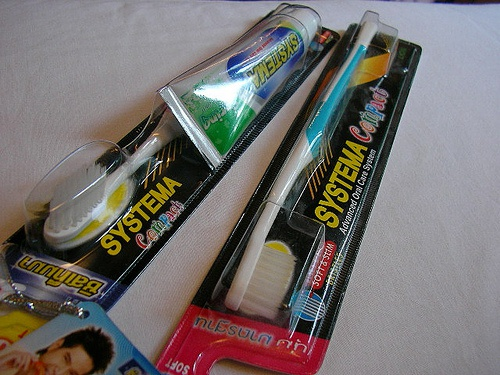Describe the objects in this image and their specific colors. I can see toothbrush in gray and darkgray tones and toothbrush in gray, darkgray, and black tones in this image. 